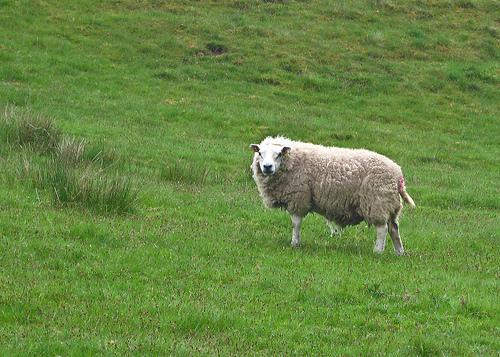Question: why would the sheep be in a field?
Choices:
A. To eat.
B. It's resting.
C. It's being sheared.
D. It's sleeping.
Answer with the letter. Answer: A Question: how is this sheep standing?
Choices:
A. Facing the camera.
B. Sideways.
C. On all fours.
D. With its back to the camera.
Answer with the letter. Answer: C 